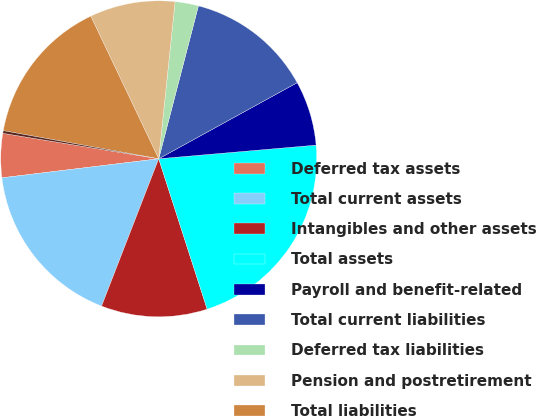<chart> <loc_0><loc_0><loc_500><loc_500><pie_chart><fcel>Deferred tax assets<fcel>Total current assets<fcel>Intangibles and other assets<fcel>Total assets<fcel>Payroll and benefit-related<fcel>Total current liabilities<fcel>Deferred tax liabilities<fcel>Pension and postretirement<fcel>Total liabilities<fcel>Accumulated other<nl><fcel>4.5%<fcel>17.19%<fcel>10.85%<fcel>21.42%<fcel>6.62%<fcel>12.96%<fcel>2.39%<fcel>8.73%<fcel>15.08%<fcel>0.27%<nl></chart> 